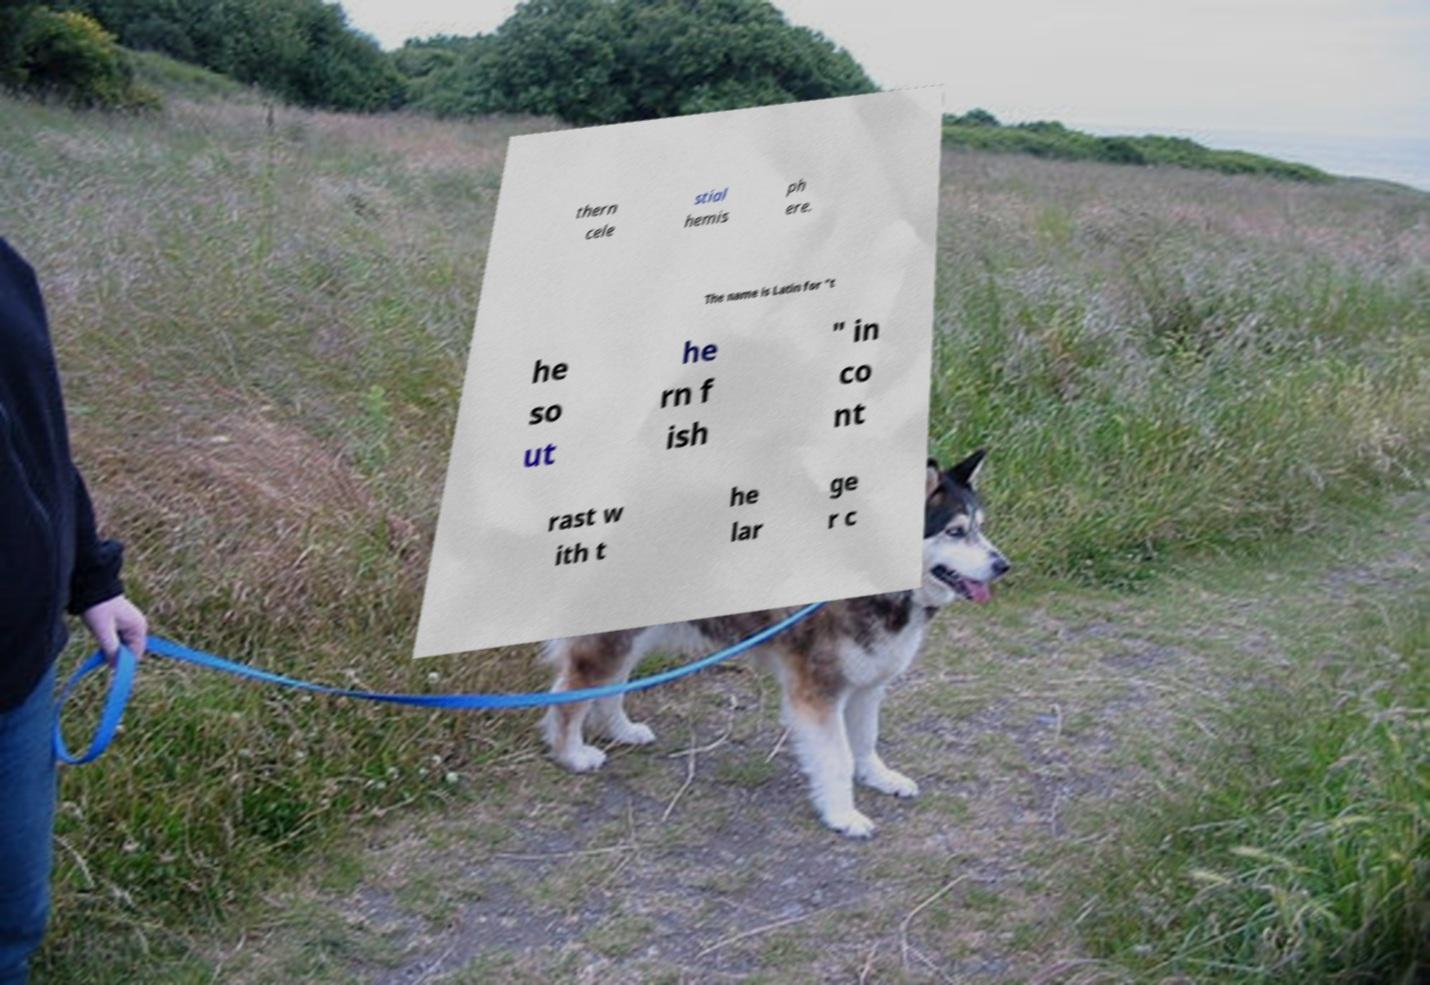For documentation purposes, I need the text within this image transcribed. Could you provide that? thern cele stial hemis ph ere. The name is Latin for "t he so ut he rn f ish " in co nt rast w ith t he lar ge r c 